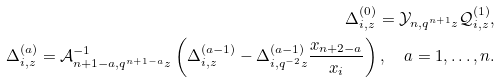<formula> <loc_0><loc_0><loc_500><loc_500>\Delta ^ { ( 0 ) } _ { i , z } = \mathcal { Y } _ { n , q ^ { n + 1 } z } \mathcal { Q } ^ { ( 1 ) } _ { i , z } , \\ \Delta ^ { ( a ) } _ { i , z } = \mathcal { A } _ { n + 1 - a , q ^ { n + 1 - a } z } ^ { - 1 } \left ( \Delta ^ { ( a - 1 ) } _ { i , z } - \Delta ^ { ( a - 1 ) } _ { i , q ^ { - 2 } z } \frac { x _ { n + 2 - a } } { x _ { i } } \right ) , \quad a = 1 , \dots , n .</formula> 